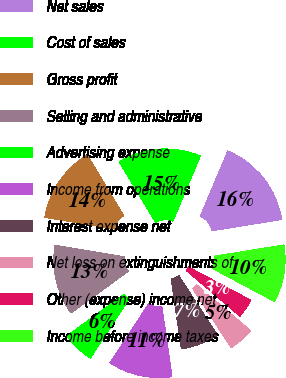Convert chart. <chart><loc_0><loc_0><loc_500><loc_500><pie_chart><fcel>Net sales<fcel>Cost of sales<fcel>Gross profit<fcel>Selling and administrative<fcel>Advertising expense<fcel>Income from operations<fcel>Interest expense net<fcel>Net loss on extinguishments of<fcel>Other (expense) income net<fcel>Income before income taxes<nl><fcel>16.09%<fcel>14.94%<fcel>13.79%<fcel>12.64%<fcel>5.75%<fcel>11.49%<fcel>6.9%<fcel>4.6%<fcel>3.45%<fcel>10.34%<nl></chart> 